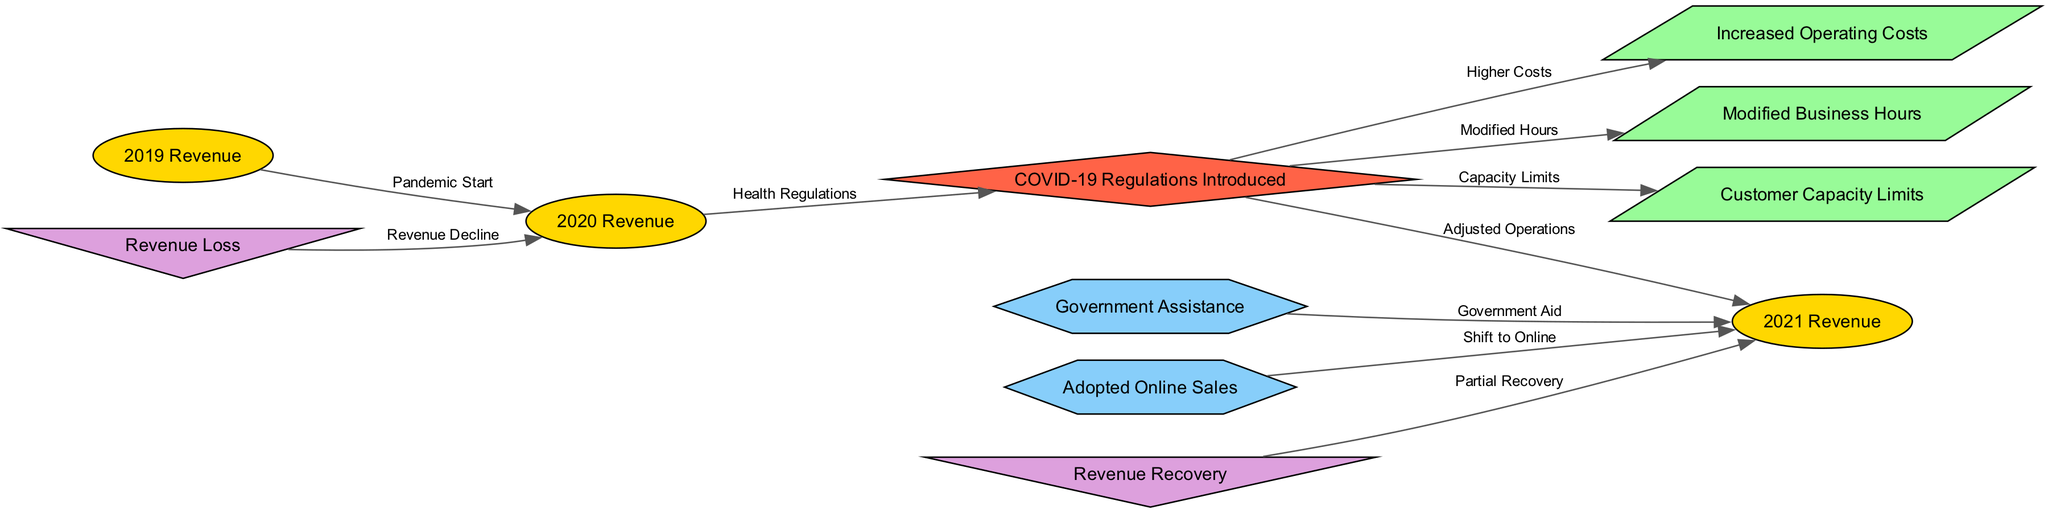What is the revenue for 2019? The diagram states the revenue for 2019 as one of the nodes labeled "2019 Revenue." It appears as an ellipse, which typically indicates a revenue figure.
Answer: 2019 Revenue What is the relationship between 2020 Revenue and COVID-19 Regulations Introduced? The edge connecting the node labeled "2020 Revenue" to the node labeled "COVID-19 Regulations Introduced" indicates the introduction of health regulations occurred during 2020, impacting the revenue. This is represented by an arrow with the label "Health Regulations."
Answer: Health Regulations How many nodes represent revenue in the diagram? The nodes labeled "2019 Revenue," "2020 Revenue," and "2021 Revenue" represent revenue in the diagram. Counting these gives a total of three revenue nodes.
Answer: Three What impact did government assistance have on revenue? The edge from the node labeled "Government Assistance" to "2021 Revenue" suggests that government aid positively influenced the recovery of revenue in 2021, helping to boost earnings.
Answer: Positive influence Which node represents increased operating costs? The node labeled "Increased Operating Costs" is clearly marked as one of the impacts of COVID-19 regulations. This node is shaped as a parallelogram and showcases the additional costs incurred by the regulations.
Answer: Increased Operating Costs What directly caused revenue loss in 2020? The edge labeled "Revenue Decline" connects the node for "2020 Revenue" to the node for "Revenue Loss," indicating that factors related to the health regulations and operations during the pandemic led to a direct decrease in revenue.
Answer: Health regulations Which strategy was adopted to help recover revenue in 2021? The diagram features a node labeled "Adopted Online Sales," which connects to "2021 Revenue." This indicates that transitioning to online sales was a strategy implemented to enhance revenue recovery following the introduction of health regulations.
Answer: Adopted Online Sales What is the final state of revenue indicated in the diagram? The diagram features "Revenue Recovery" connected to "2021 Revenue," indicating that after facing challenges led by health regulations, a degree of recovery has been achieved in 2021.
Answer: Revenue Recovery Which regulations were specifically mentioned as modifications that affected operations? The diagram includes nodes for "Modified Business Hours" and "Customer Capacity Limits," both of which stem from "COVID-19 Regulations Introduced." These modifications contributed to the adjustments made in local business operations.
Answer: Modified Business Hours and Customer Capacity Limits 